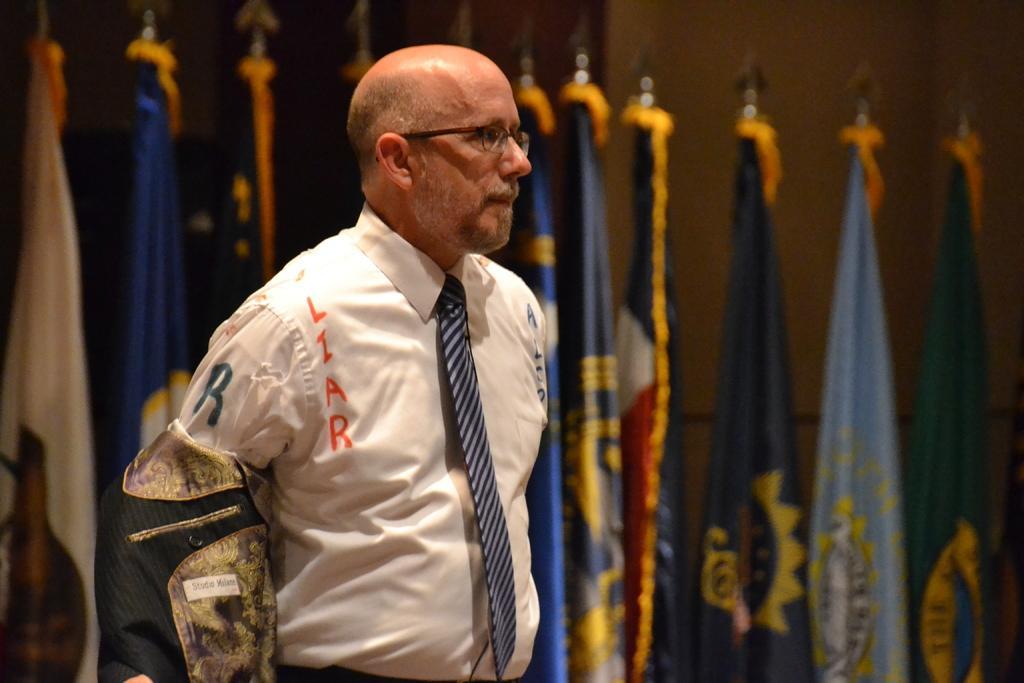Could you give a brief overview of what you see in this image? In this image there is a person standing, he is truncated towards the bottom of the image, there are flags truncated towards the bottom of the image, at the background of the image there is a wall truncated. 